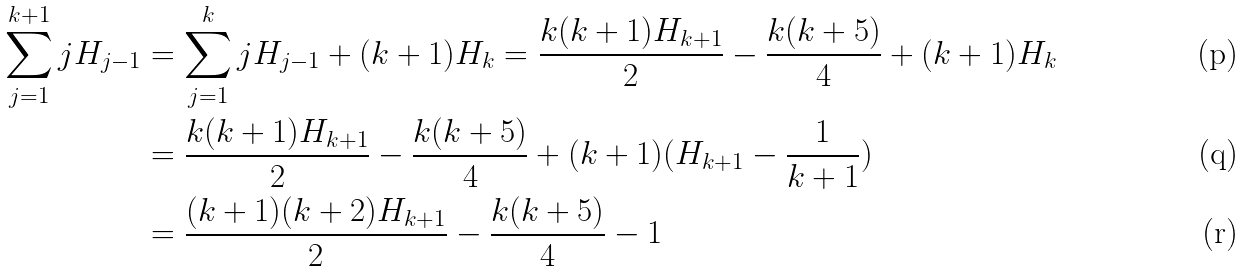Convert formula to latex. <formula><loc_0><loc_0><loc_500><loc_500>\sum _ { j = 1 } ^ { k + 1 } j H _ { j - 1 } & = \sum _ { j = 1 } ^ { k } j H _ { j - 1 } + ( k + 1 ) H _ { k } = \frac { k ( k + 1 ) H _ { k + 1 } } { 2 } - \frac { k ( k + 5 ) } { 4 } + ( k + 1 ) H _ { k } \\ & = \frac { k ( k + 1 ) H _ { k + 1 } } { 2 } - \frac { k ( k + 5 ) } { 4 } + ( k + 1 ) ( H _ { k + 1 } - \frac { 1 } { k + 1 } ) \\ & = \frac { ( k + 1 ) ( k + 2 ) H _ { k + 1 } } { 2 } - \frac { k ( k + 5 ) } { 4 } - 1</formula> 